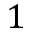<formula> <loc_0><loc_0><loc_500><loc_500>1</formula> 